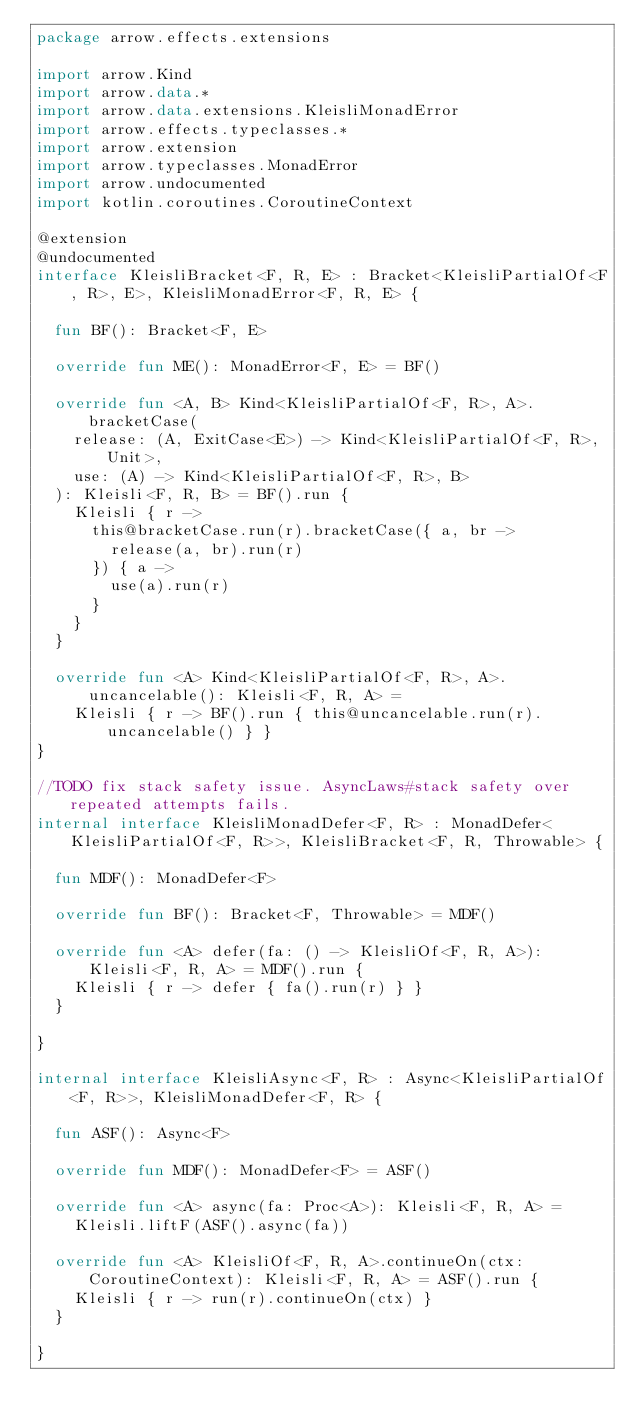Convert code to text. <code><loc_0><loc_0><loc_500><loc_500><_Kotlin_>package arrow.effects.extensions

import arrow.Kind
import arrow.data.*
import arrow.data.extensions.KleisliMonadError
import arrow.effects.typeclasses.*
import arrow.extension
import arrow.typeclasses.MonadError
import arrow.undocumented
import kotlin.coroutines.CoroutineContext

@extension
@undocumented
interface KleisliBracket<F, R, E> : Bracket<KleisliPartialOf<F, R>, E>, KleisliMonadError<F, R, E> {

  fun BF(): Bracket<F, E>

  override fun ME(): MonadError<F, E> = BF()

  override fun <A, B> Kind<KleisliPartialOf<F, R>, A>.bracketCase(
    release: (A, ExitCase<E>) -> Kind<KleisliPartialOf<F, R>, Unit>,
    use: (A) -> Kind<KleisliPartialOf<F, R>, B>
  ): Kleisli<F, R, B> = BF().run {
    Kleisli { r ->
      this@bracketCase.run(r).bracketCase({ a, br ->
        release(a, br).run(r)
      }) { a ->
        use(a).run(r)
      }
    }
  }

  override fun <A> Kind<KleisliPartialOf<F, R>, A>.uncancelable(): Kleisli<F, R, A> =
    Kleisli { r -> BF().run { this@uncancelable.run(r).uncancelable() } }
}

//TODO fix stack safety issue. AsyncLaws#stack safety over repeated attempts fails.
internal interface KleisliMonadDefer<F, R> : MonadDefer<KleisliPartialOf<F, R>>, KleisliBracket<F, R, Throwable> {

  fun MDF(): MonadDefer<F>

  override fun BF(): Bracket<F, Throwable> = MDF()

  override fun <A> defer(fa: () -> KleisliOf<F, R, A>): Kleisli<F, R, A> = MDF().run {
    Kleisli { r -> defer { fa().run(r) } }
  }

}

internal interface KleisliAsync<F, R> : Async<KleisliPartialOf<F, R>>, KleisliMonadDefer<F, R> {

  fun ASF(): Async<F>

  override fun MDF(): MonadDefer<F> = ASF()

  override fun <A> async(fa: Proc<A>): Kleisli<F, R, A> =
    Kleisli.liftF(ASF().async(fa))

  override fun <A> KleisliOf<F, R, A>.continueOn(ctx: CoroutineContext): Kleisli<F, R, A> = ASF().run {
    Kleisli { r -> run(r).continueOn(ctx) }
  }

}
</code> 